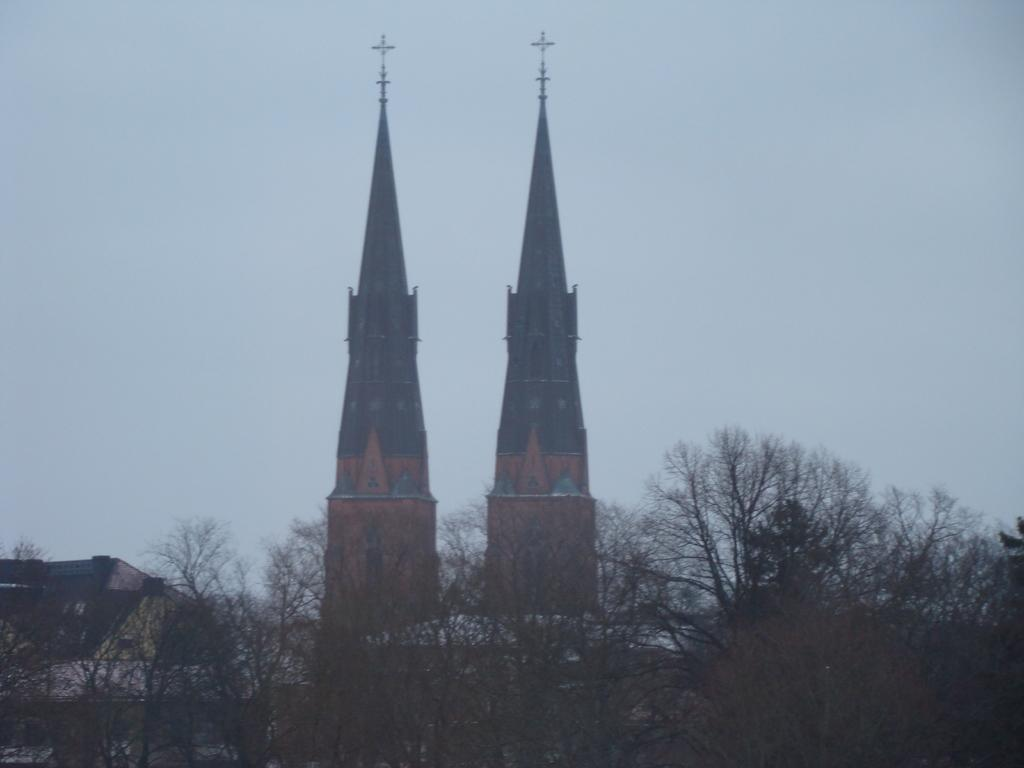What type of vegetation is at the bottom of the image? There are trees at the bottom of the image. How do the trees in the background appear? In the background, the trees appear to resemble pillars. What is visible at the top of the image? The sky is visible at the top of the image. What type of shock can be seen in the image? There is no shock present in the image. Can you describe the feather in the image? There is no feather present in the image. 